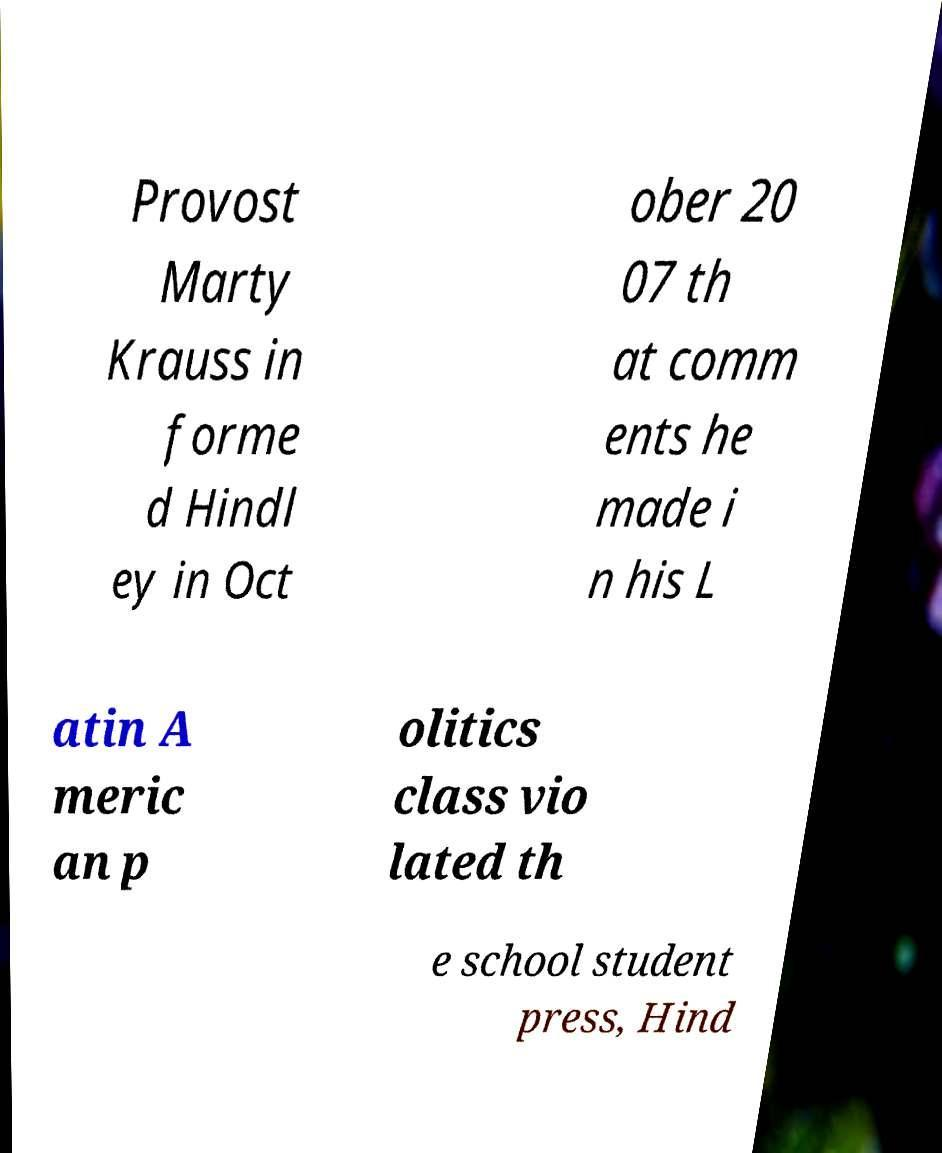There's text embedded in this image that I need extracted. Can you transcribe it verbatim? Provost Marty Krauss in forme d Hindl ey in Oct ober 20 07 th at comm ents he made i n his L atin A meric an p olitics class vio lated th e school student press, Hind 